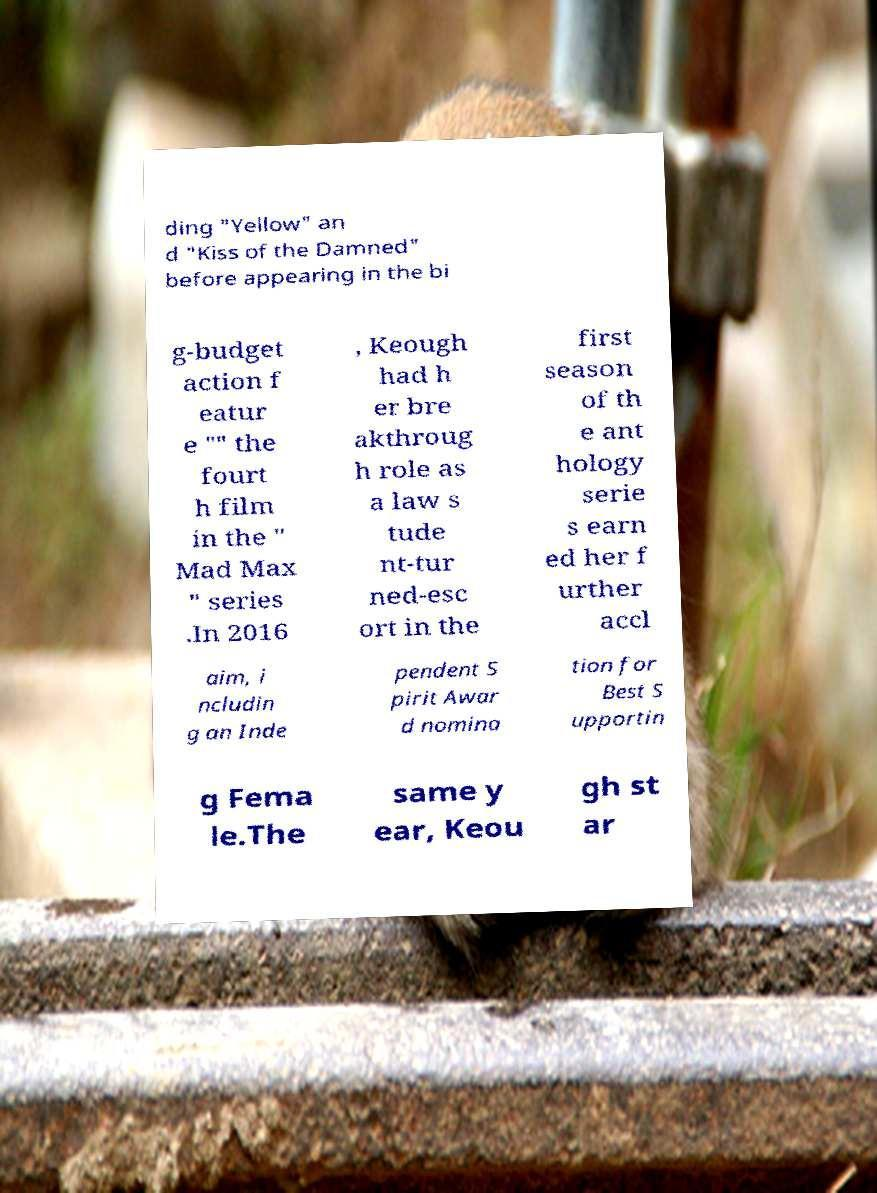For documentation purposes, I need the text within this image transcribed. Could you provide that? ding "Yellow" an d "Kiss of the Damned" before appearing in the bi g-budget action f eatur e "" the fourt h film in the " Mad Max " series .In 2016 , Keough had h er bre akthroug h role as a law s tude nt-tur ned-esc ort in the first season of th e ant hology serie s earn ed her f urther accl aim, i ncludin g an Inde pendent S pirit Awar d nomina tion for Best S upportin g Fema le.The same y ear, Keou gh st ar 